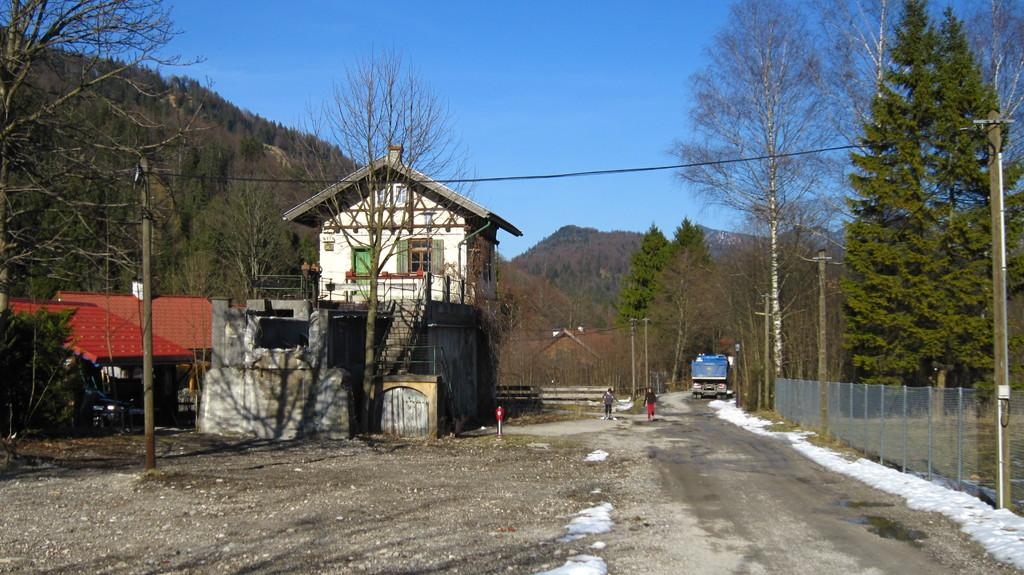What type of natural elements can be seen in the image? There are trees in the image. What man-made structures are present in the image? There are poles, houses, and a fence on the right side of the image. Can you describe the people in the image? There are persons in the image. What is the ground covered with in the image? There is snow on the ground in the image. What can be seen in the background of the image? There is a vehicle in the background of the image. Where is the notebook being used in the image? There is no notebook present in the image. What type of cart is being pulled by the persons in the image? There is no cart present in the image. 